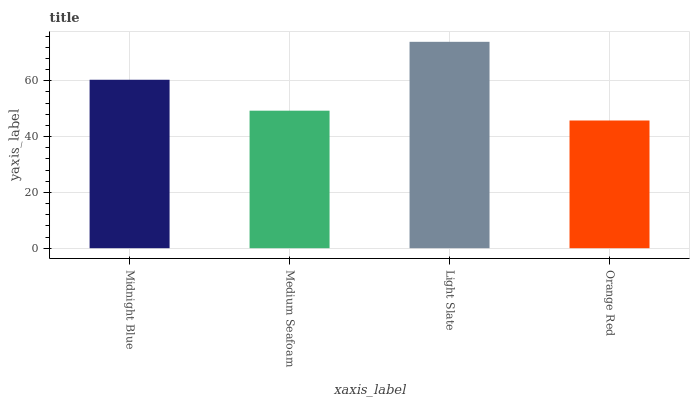Is Orange Red the minimum?
Answer yes or no. Yes. Is Light Slate the maximum?
Answer yes or no. Yes. Is Medium Seafoam the minimum?
Answer yes or no. No. Is Medium Seafoam the maximum?
Answer yes or no. No. Is Midnight Blue greater than Medium Seafoam?
Answer yes or no. Yes. Is Medium Seafoam less than Midnight Blue?
Answer yes or no. Yes. Is Medium Seafoam greater than Midnight Blue?
Answer yes or no. No. Is Midnight Blue less than Medium Seafoam?
Answer yes or no. No. Is Midnight Blue the high median?
Answer yes or no. Yes. Is Medium Seafoam the low median?
Answer yes or no. Yes. Is Light Slate the high median?
Answer yes or no. No. Is Orange Red the low median?
Answer yes or no. No. 